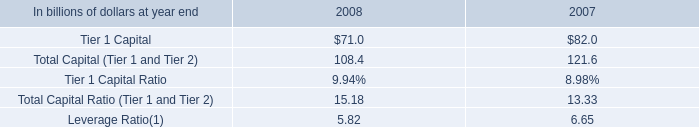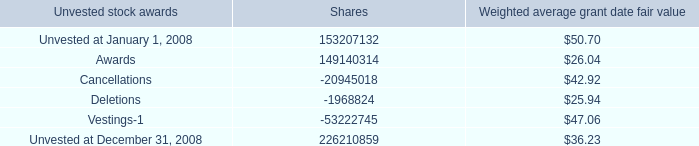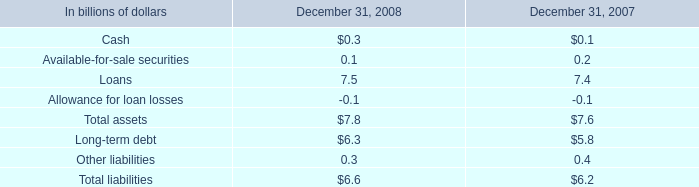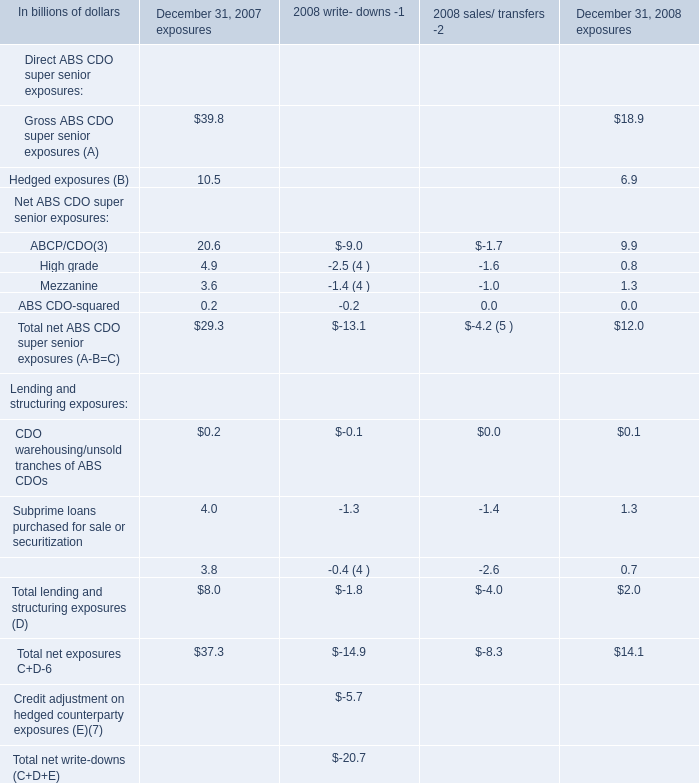What was the total amount of Net ABS CDO super senior exposures in 2007 ? (in billions) 
Computations: (((20.6 + 4.9) + 3.6) + 0.2)
Answer: 29.3. 